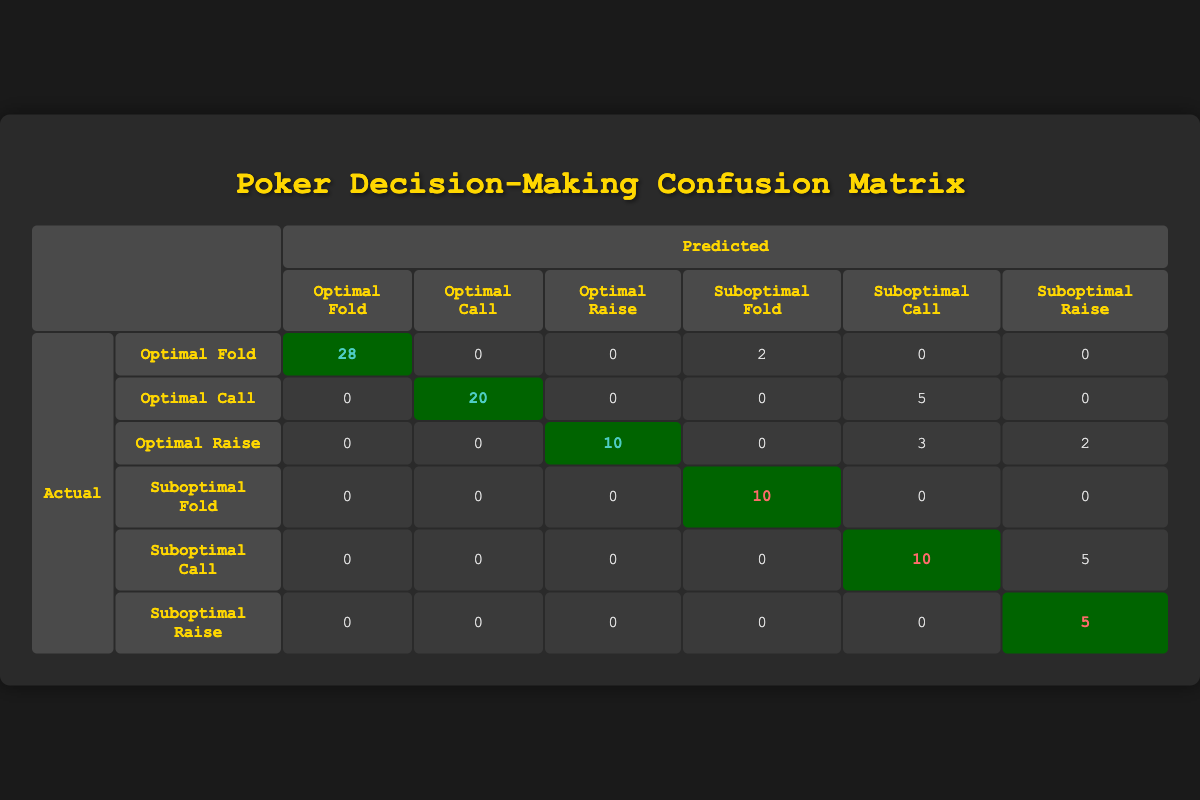What is the number of predicted Optimal Folds? The table shows that the predicted count of Optimal Folds is 28, which is indicated in the corresponding cell under the "Predicted" section.
Answer: 28 How many decisions were optimally made in the 'Optimal Call' category? Referring to the table, the number of optimal decisions made in the Optimal Call category is 20, as seen in the respective cell.
Answer: 20 What is the total number of Suboptimal Calls predicted? The table indicates there are 10 Suboptimal Calls predicted, represented in the appropriate cell under the "Predicted" column.
Answer: 10 Is the number of Suboptimal Raises greater than that of Optimal Raises? For Optimal Raises, the predicted count is 10, and for Suboptimal Raises, it is 5. Since 10 is greater than 5, the statement is true.
Answer: Yes What is the difference between the actual Optimal Calls and the predicted Optimal Calls? The actual Optimal Calls count is 25 and the predicted count is 20. The difference is calculated as 25 - 20 = 5.
Answer: 5 What is the total number of Suboptimal decisions predicted? The total number of Suboptimal decisions can be found by adding the predicted counts for Suboptimal Fold (12), Suboptimal Call (10), and Suboptimal Raise (7). Thus, the total is 12 + 10 + 7 = 29.
Answer: 29 How many actual decisions were optimal versus suboptimal overall? The sum of actual Optimal decisions is 30 (Optimal Fold) + 25 (Optimal Call) + 15 (Optimal Raise) = 70 and Suboptimal decisions total to 10 (Suboptimal Fold) + 15 (Suboptimal Call) + 5 (Suboptimal Raise) = 30. So, optimal decisions are 70 and suboptimal are 30.
Answer: Optimal: 70, Suboptimal: 30 Are there more actual Optimal Folds than actual Suboptimal Folds? The actual Optimal Folds count is 30 and the actual Suboptimal Folds count is 10. Since 30 is greater than 10, the statement is true.
Answer: Yes What is the percentage of predicted Optimal Raises to the total number of predicted actions? The total predicted actions are 28 (Optimal Fold) + 20 (Optimal Call) + 10 (Optimal Raise) + 12 (Suboptimal Fold) + 18 (Suboptimal Call) + 7 (Suboptimal Raise) = 105. The percentage of predicted Optimal Raises is (10/105) * 100 = 9.52%.
Answer: 9.52% 